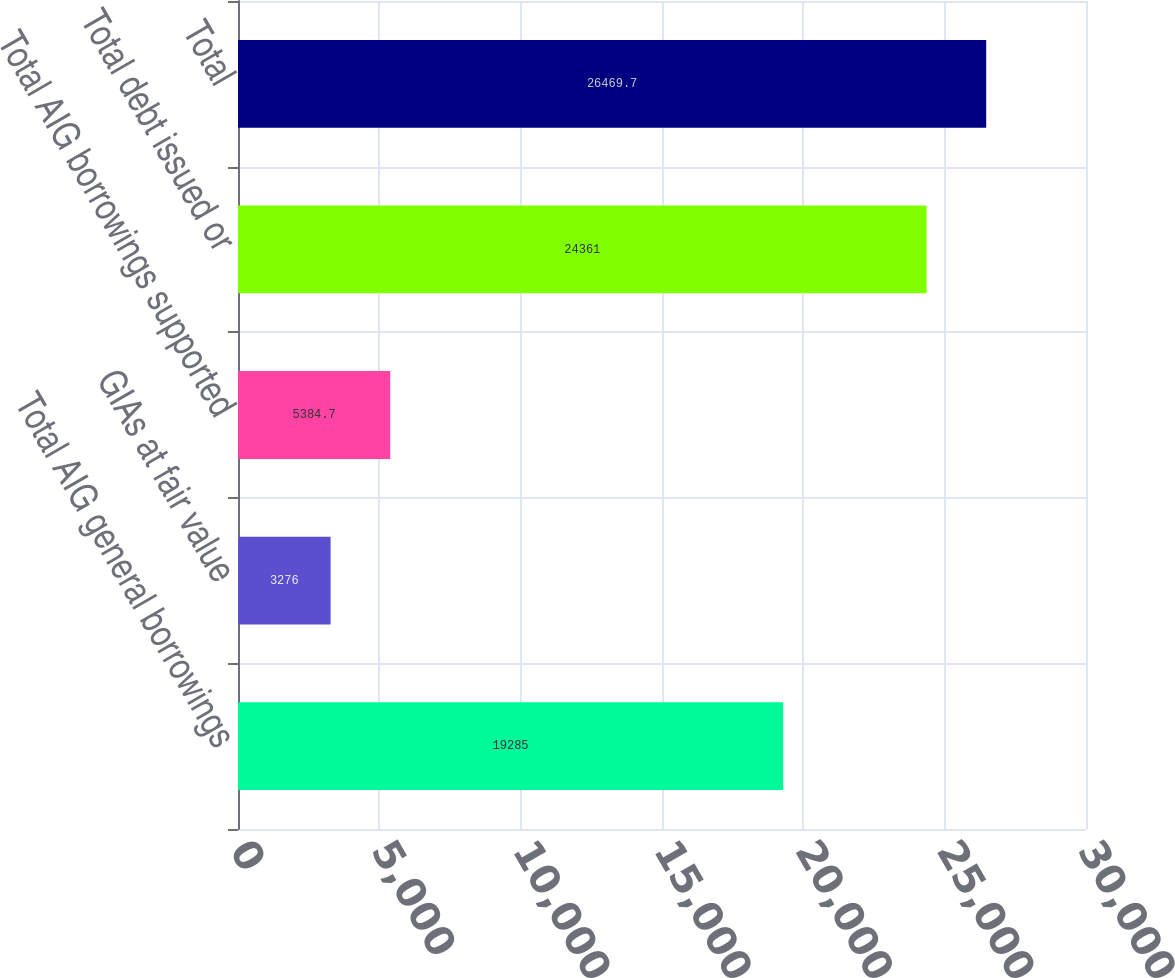Convert chart. <chart><loc_0><loc_0><loc_500><loc_500><bar_chart><fcel>Total AIG general borrowings<fcel>GIAs at fair value<fcel>Total AIG borrowings supported<fcel>Total debt issued or<fcel>Total<nl><fcel>19285<fcel>3276<fcel>5384.7<fcel>24361<fcel>26469.7<nl></chart> 